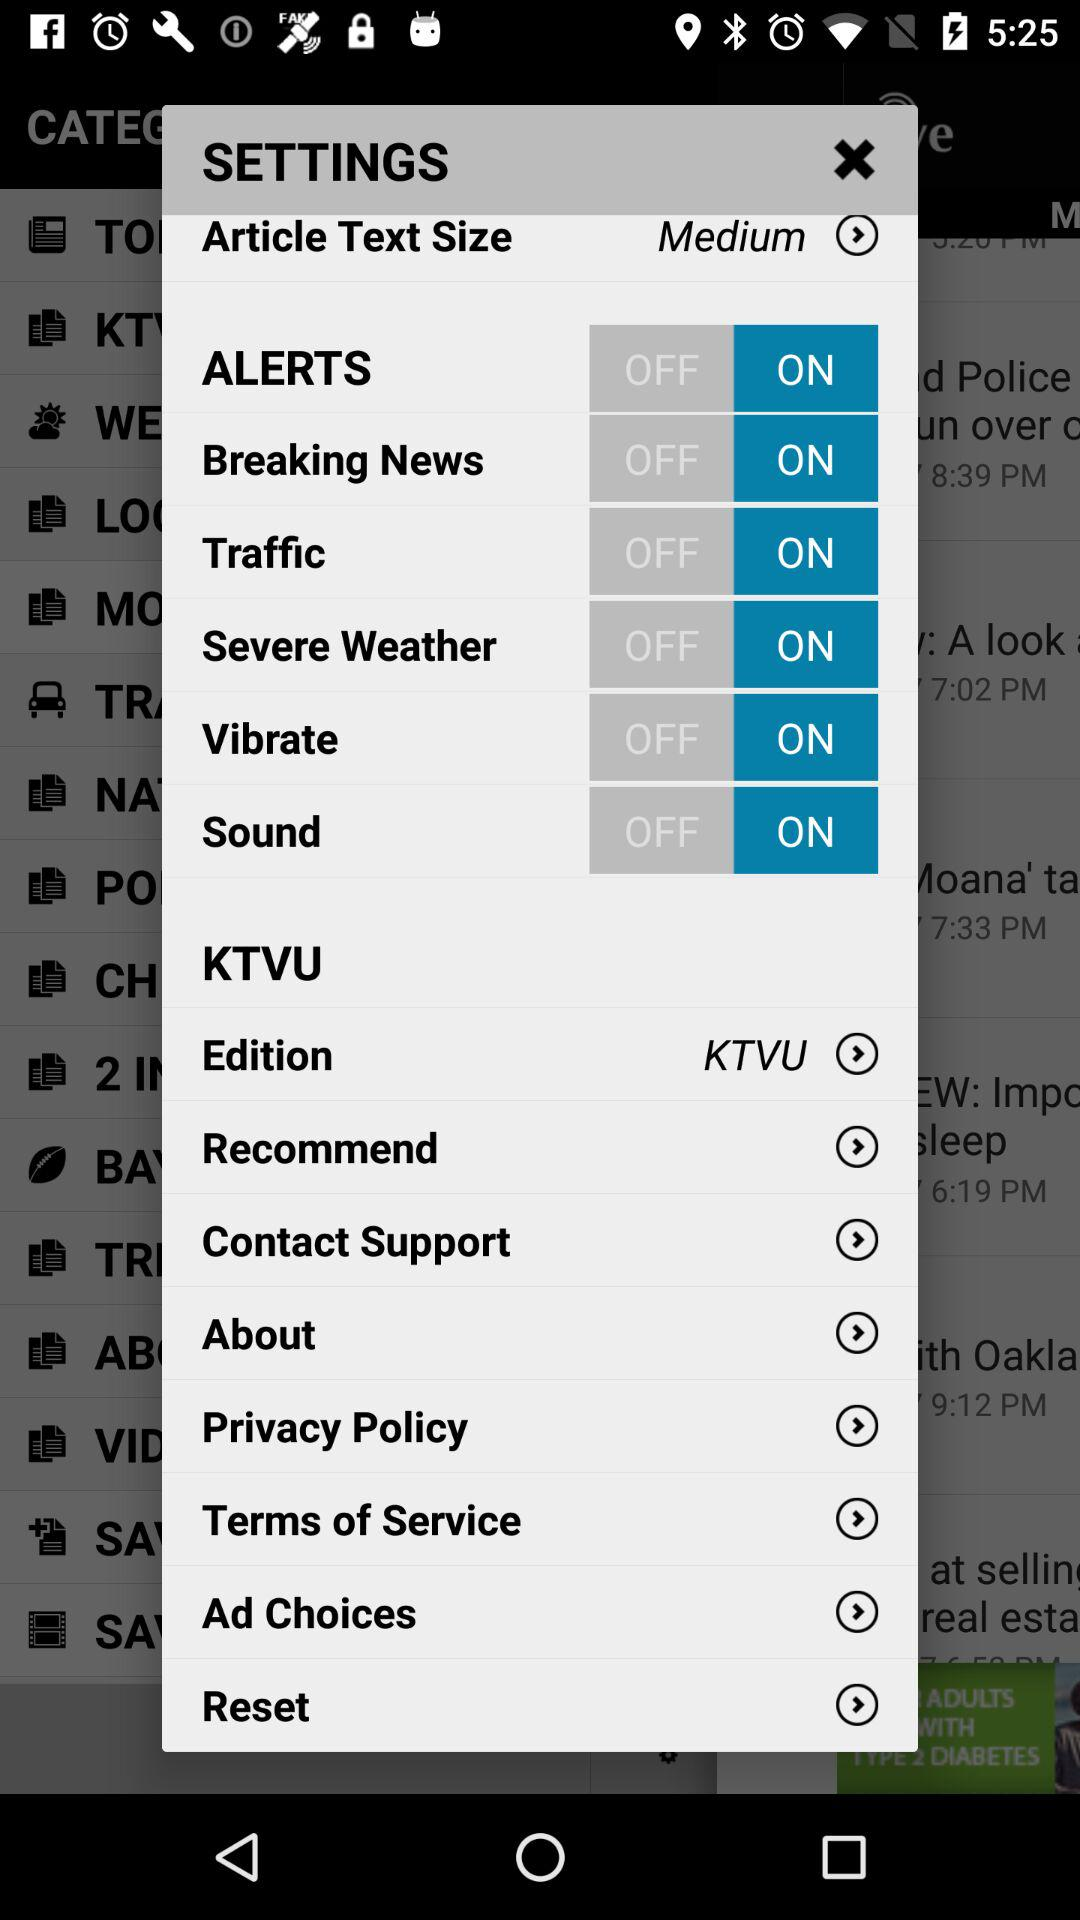What is the status of "Traffic"? The status is "on". 